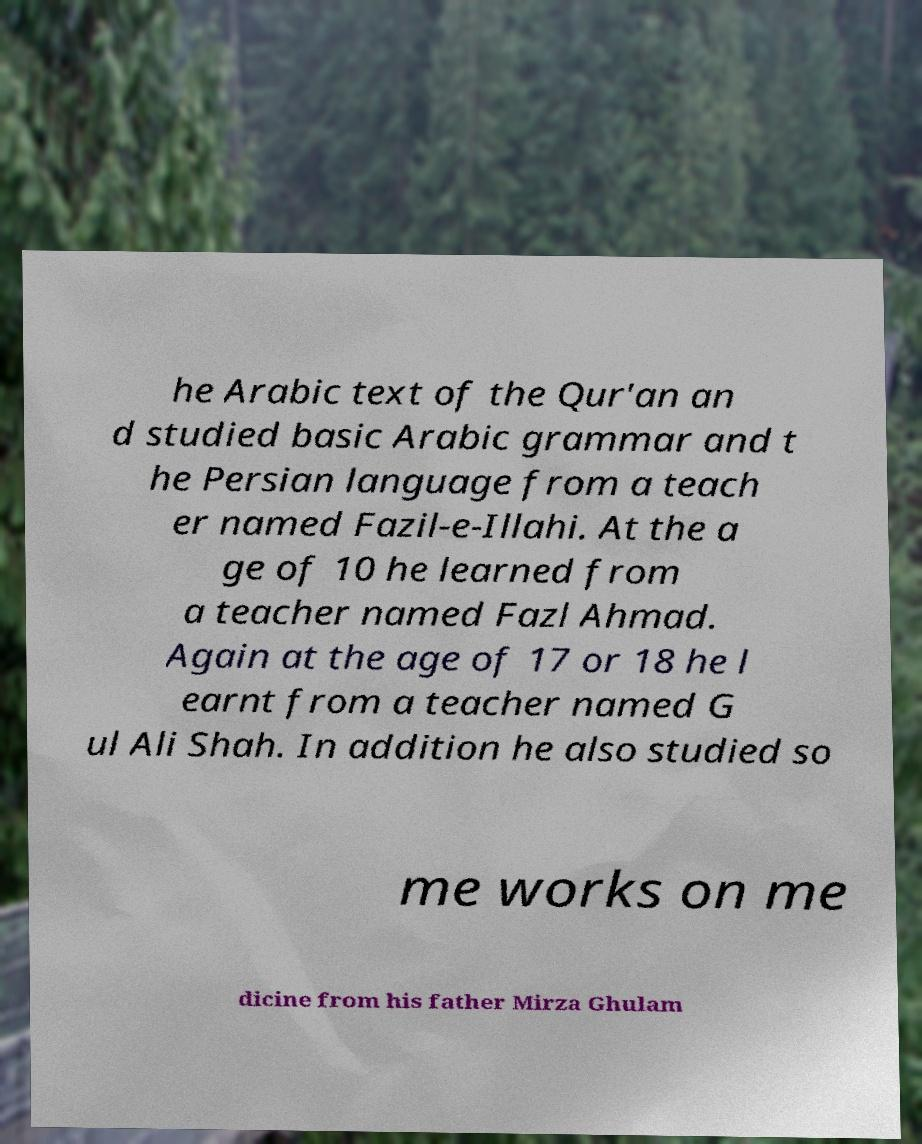Can you accurately transcribe the text from the provided image for me? he Arabic text of the Qur'an an d studied basic Arabic grammar and t he Persian language from a teach er named Fazil-e-Illahi. At the a ge of 10 he learned from a teacher named Fazl Ahmad. Again at the age of 17 or 18 he l earnt from a teacher named G ul Ali Shah. In addition he also studied so me works on me dicine from his father Mirza Ghulam 